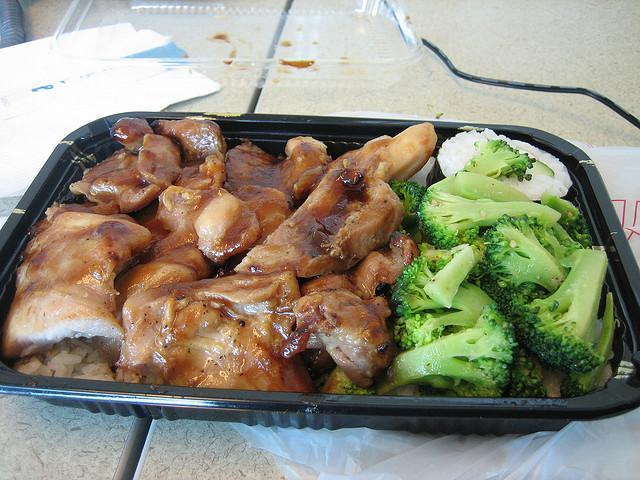Evaluate: Does the caption "The dining table consists of the broccoli." match the image?
Answer yes or no. No. 